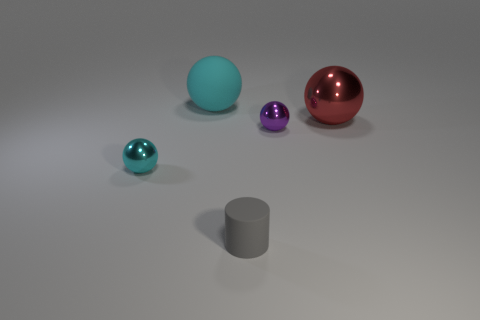How many objects are either tiny blue metal things or metallic objects in front of the big red thing?
Your answer should be very brief. 2. There is a small sphere that is left of the gray object; are there any big cyan things behind it?
Provide a succinct answer. Yes. What is the shape of the rubber thing that is in front of the tiny metallic thing to the right of the cyan ball in front of the big metal sphere?
Provide a succinct answer. Cylinder. There is a tiny thing that is both behind the gray matte cylinder and to the right of the big cyan matte ball; what color is it?
Offer a very short reply. Purple. What shape is the matte object that is behind the big shiny object?
Give a very brief answer. Sphere. What shape is the thing that is the same material as the big cyan ball?
Offer a terse response. Cylinder. How many rubber things are small cyan spheres or large yellow spheres?
Provide a succinct answer. 0. How many big matte balls are in front of the large red metal ball in front of the big sphere behind the red shiny thing?
Make the answer very short. 0. Is the size of the metallic sphere that is left of the gray thing the same as the matte object that is left of the gray cylinder?
Provide a short and direct response. No. There is a large red thing that is the same shape as the purple object; what is it made of?
Provide a short and direct response. Metal. 